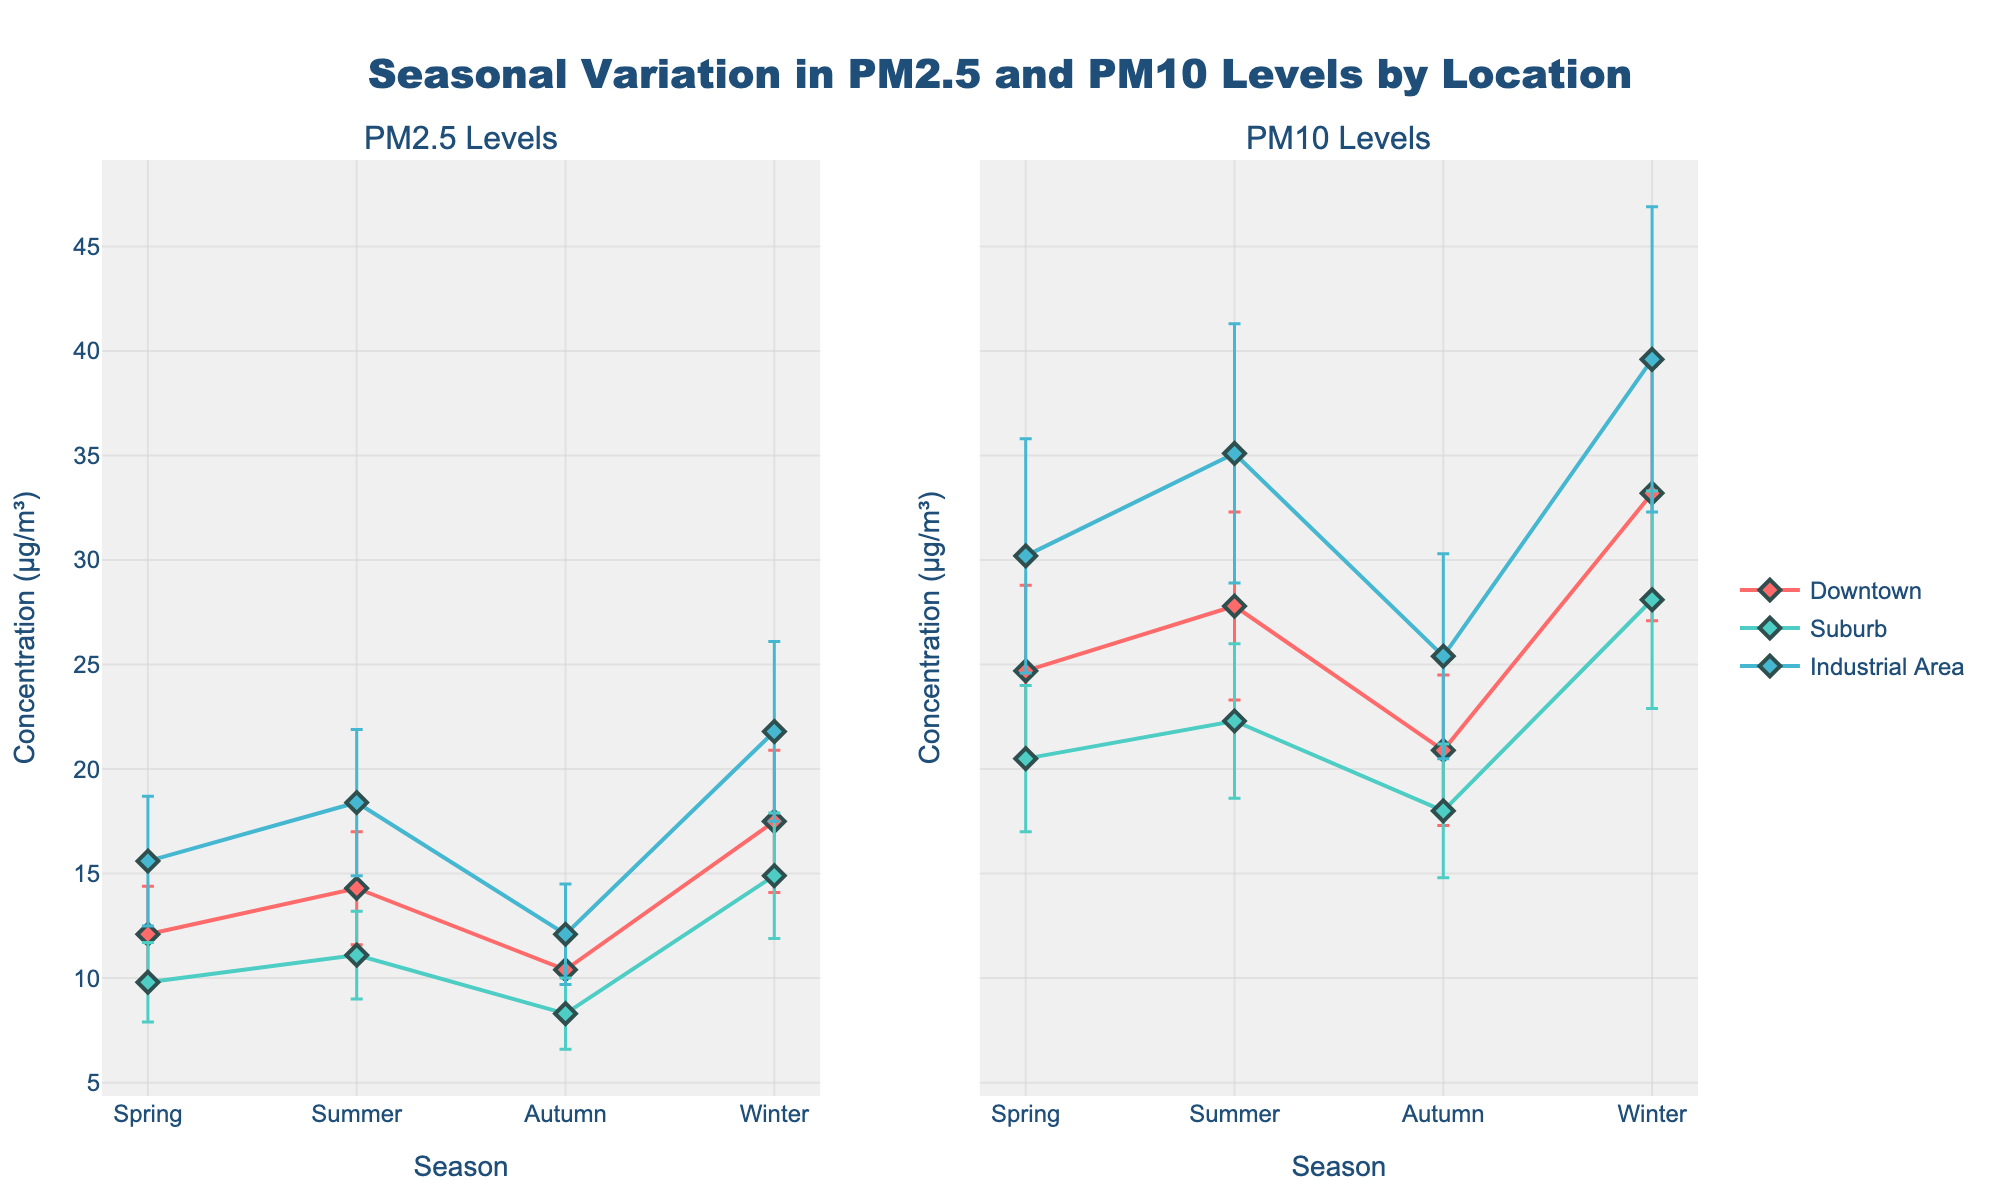What are the mean PM2.5 levels in the downtown area during winter? Locate the "Downtown" data point for "Winter" in the PM2.5 subplot (left). The mean PM2.5 value is displayed at the intersection of the "Winter" season and the downtown data point.
Answer: 17.5 What season shows the highest mean PM10 levels in the industrial area? Observe the PM10 subplot (right) and locate the industrial area's data points across all seasons. Identify which season has the highest mean value. The winter season has the highest mean PM10 level in the industrial area.
Answer: Winter Which location has the lowest mean PM2.5 level during autumn? Check the PM2.5 subplot (left) and look for the "Autumn" season. Compare the mean PM2.5 levels of the three locations. The suburb has the lowest mean PM2.5 level in autumn.
Answer: Suburb What is the difference in mean PM10 levels between the summer and winter seasons in the downtown area? In the PM10 subplot (right), find the downtown data points for "Summer" and "Winter". The respective mean PM10 levels are 27.8 and 33.2. Calculate the difference: 33.2 - 27.8 = 5.4
Answer: 5.4 Which season has the smallest uncertainty in mean PM2.5 levels in the suburb? Look at the suburb data across all seasons in the PM2.5 subplot (left) and compare the lengths of the error bars. Autumn has the smallest uncertainty (shortest error bar).
Answer: Autumn Are the mean PM2.5 levels in the downtown area higher in summer or spring? Compare the mean PM2.5 levels for the downtown area in "Summer" and "Spring" on the PM2.5 subplot (left). The values are 14.3 for summer and 12.1 for spring. Summer has higher mean levels.
Answer: Summer By how much do the mean PM2.5 levels in the industrial area change from spring to autumn? In the PM2.5 subplot (left), find the industrial area's data points for "Spring" and "Autumn". The respective mean PM2.5 levels are 15.6 and 12.1. Calculate the change: 15.6 - 12.1 = 3.5
Answer: 3.5 Which season experiences the highest variability in PM10 levels in the suburb? Observe the lengths of the error bars for the suburb data across all seasons in the PM10 subplot (right). Winter has the longest error bar, indicating the highest variability in PM10 levels.
Answer: Winter What are the mean PM10 and its uncertainty interval for the industrial area during the spring? Check the spring data point for the industrial area in the PM10 subplot (right). The mean PM10 level is 30.2, and the uncertainty is represented by the standard deviation: 30.2 ± 5.6.
Answer: 30.2 ± 5.6 